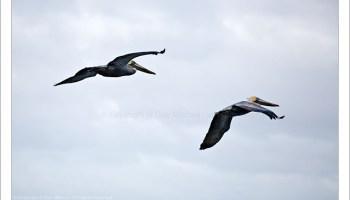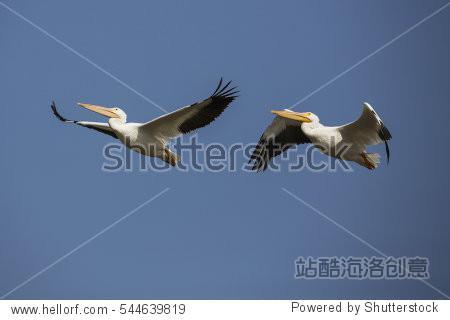The first image is the image on the left, the second image is the image on the right. Considering the images on both sides, is "All pelicans are in flight, left and right images contain the same number of pelican-type birds, and no single image contains more than two pelicans." valid? Answer yes or no. Yes. The first image is the image on the left, the second image is the image on the right. For the images shown, is this caption "The right image contains exactly two birds flying in the sky." true? Answer yes or no. Yes. 